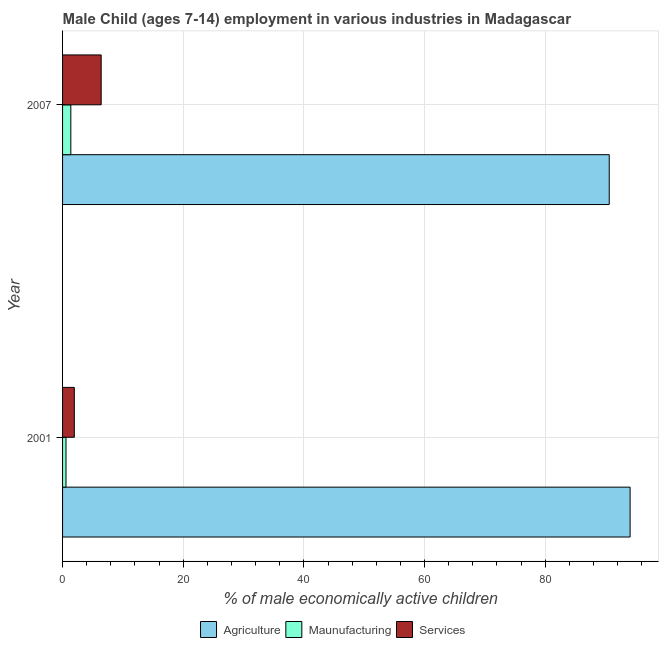How many different coloured bars are there?
Offer a very short reply. 3. How many groups of bars are there?
Make the answer very short. 2. Are the number of bars per tick equal to the number of legend labels?
Provide a short and direct response. Yes. Are the number of bars on each tick of the Y-axis equal?
Give a very brief answer. Yes. How many bars are there on the 1st tick from the bottom?
Your answer should be compact. 3. In how many cases, is the number of bars for a given year not equal to the number of legend labels?
Offer a terse response. 0. What is the percentage of economically active children in agriculture in 2007?
Provide a succinct answer. 90.62. Across all years, what is the minimum percentage of economically active children in agriculture?
Your answer should be compact. 90.62. In which year was the percentage of economically active children in services maximum?
Your answer should be very brief. 2007. What is the total percentage of economically active children in services in the graph?
Make the answer very short. 8.35. What is the difference between the percentage of economically active children in agriculture in 2001 and that in 2007?
Your answer should be compact. 3.46. What is the difference between the percentage of economically active children in services in 2001 and the percentage of economically active children in manufacturing in 2007?
Offer a terse response. 0.58. What is the average percentage of economically active children in agriculture per year?
Provide a succinct answer. 92.35. In the year 2001, what is the difference between the percentage of economically active children in agriculture and percentage of economically active children in services?
Give a very brief answer. 92.13. What is the ratio of the percentage of economically active children in services in 2001 to that in 2007?
Provide a short and direct response. 0.3. Is the percentage of economically active children in agriculture in 2001 less than that in 2007?
Your answer should be compact. No. In how many years, is the percentage of economically active children in services greater than the average percentage of economically active children in services taken over all years?
Your answer should be compact. 1. What does the 2nd bar from the top in 2001 represents?
Provide a short and direct response. Maunufacturing. What does the 3rd bar from the bottom in 2001 represents?
Offer a very short reply. Services. Is it the case that in every year, the sum of the percentage of economically active children in agriculture and percentage of economically active children in manufacturing is greater than the percentage of economically active children in services?
Provide a succinct answer. Yes. How many years are there in the graph?
Offer a very short reply. 2. Does the graph contain grids?
Your answer should be compact. Yes. How many legend labels are there?
Ensure brevity in your answer.  3. What is the title of the graph?
Give a very brief answer. Male Child (ages 7-14) employment in various industries in Madagascar. Does "Capital account" appear as one of the legend labels in the graph?
Make the answer very short. No. What is the label or title of the X-axis?
Provide a short and direct response. % of male economically active children. What is the label or title of the Y-axis?
Offer a very short reply. Year. What is the % of male economically active children in Agriculture in 2001?
Give a very brief answer. 94.08. What is the % of male economically active children in Maunufacturing in 2001?
Ensure brevity in your answer.  0.57. What is the % of male economically active children of Services in 2001?
Make the answer very short. 1.95. What is the % of male economically active children in Agriculture in 2007?
Ensure brevity in your answer.  90.62. What is the % of male economically active children of Maunufacturing in 2007?
Your answer should be compact. 1.37. What is the % of male economically active children in Services in 2007?
Your answer should be compact. 6.4. Across all years, what is the maximum % of male economically active children in Agriculture?
Make the answer very short. 94.08. Across all years, what is the maximum % of male economically active children of Maunufacturing?
Give a very brief answer. 1.37. Across all years, what is the maximum % of male economically active children of Services?
Your answer should be very brief. 6.4. Across all years, what is the minimum % of male economically active children of Agriculture?
Make the answer very short. 90.62. Across all years, what is the minimum % of male economically active children in Maunufacturing?
Make the answer very short. 0.57. Across all years, what is the minimum % of male economically active children in Services?
Offer a terse response. 1.95. What is the total % of male economically active children in Agriculture in the graph?
Provide a short and direct response. 184.7. What is the total % of male economically active children of Maunufacturing in the graph?
Make the answer very short. 1.94. What is the total % of male economically active children in Services in the graph?
Keep it short and to the point. 8.35. What is the difference between the % of male economically active children of Agriculture in 2001 and that in 2007?
Your response must be concise. 3.46. What is the difference between the % of male economically active children in Services in 2001 and that in 2007?
Provide a succinct answer. -4.45. What is the difference between the % of male economically active children in Agriculture in 2001 and the % of male economically active children in Maunufacturing in 2007?
Make the answer very short. 92.71. What is the difference between the % of male economically active children of Agriculture in 2001 and the % of male economically active children of Services in 2007?
Offer a very short reply. 87.68. What is the difference between the % of male economically active children of Maunufacturing in 2001 and the % of male economically active children of Services in 2007?
Your answer should be compact. -5.83. What is the average % of male economically active children of Agriculture per year?
Provide a succinct answer. 92.35. What is the average % of male economically active children in Maunufacturing per year?
Offer a very short reply. 0.97. What is the average % of male economically active children of Services per year?
Provide a short and direct response. 4.17. In the year 2001, what is the difference between the % of male economically active children of Agriculture and % of male economically active children of Maunufacturing?
Provide a succinct answer. 93.51. In the year 2001, what is the difference between the % of male economically active children in Agriculture and % of male economically active children in Services?
Provide a succinct answer. 92.13. In the year 2001, what is the difference between the % of male economically active children in Maunufacturing and % of male economically active children in Services?
Your response must be concise. -1.38. In the year 2007, what is the difference between the % of male economically active children in Agriculture and % of male economically active children in Maunufacturing?
Offer a very short reply. 89.25. In the year 2007, what is the difference between the % of male economically active children of Agriculture and % of male economically active children of Services?
Provide a short and direct response. 84.22. In the year 2007, what is the difference between the % of male economically active children in Maunufacturing and % of male economically active children in Services?
Give a very brief answer. -5.03. What is the ratio of the % of male economically active children in Agriculture in 2001 to that in 2007?
Offer a very short reply. 1.04. What is the ratio of the % of male economically active children in Maunufacturing in 2001 to that in 2007?
Provide a short and direct response. 0.42. What is the ratio of the % of male economically active children in Services in 2001 to that in 2007?
Your response must be concise. 0.3. What is the difference between the highest and the second highest % of male economically active children in Agriculture?
Your response must be concise. 3.46. What is the difference between the highest and the second highest % of male economically active children of Services?
Your answer should be very brief. 4.45. What is the difference between the highest and the lowest % of male economically active children in Agriculture?
Offer a very short reply. 3.46. What is the difference between the highest and the lowest % of male economically active children in Services?
Ensure brevity in your answer.  4.45. 